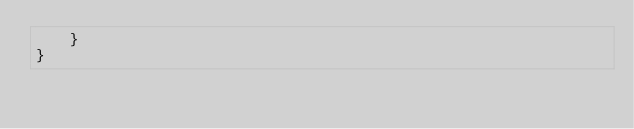Convert code to text. <code><loc_0><loc_0><loc_500><loc_500><_Java_>    }
}
</code> 